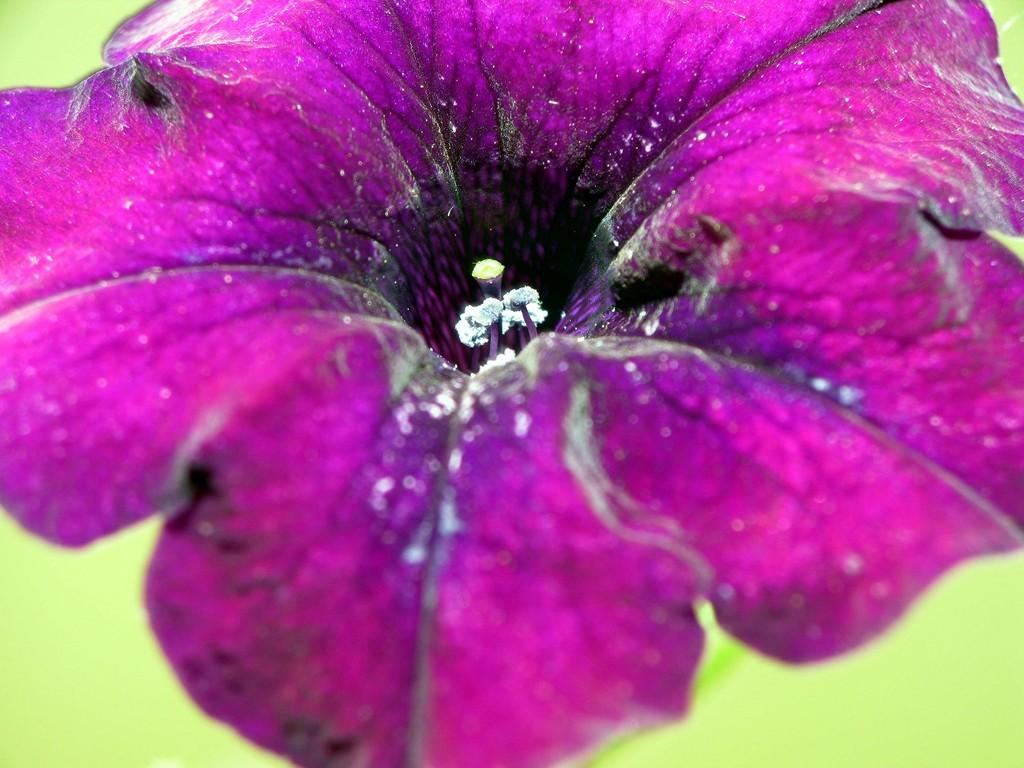What type of flower is in the image? There is a pink color flower in the image. What color is the background of the image? The background of the image is green. Can you tell if the image was taken during the day or night? The image was likely taken during the day. Can you see any rabbits eating bread in the image? There are no rabbits or bread present in the image. 